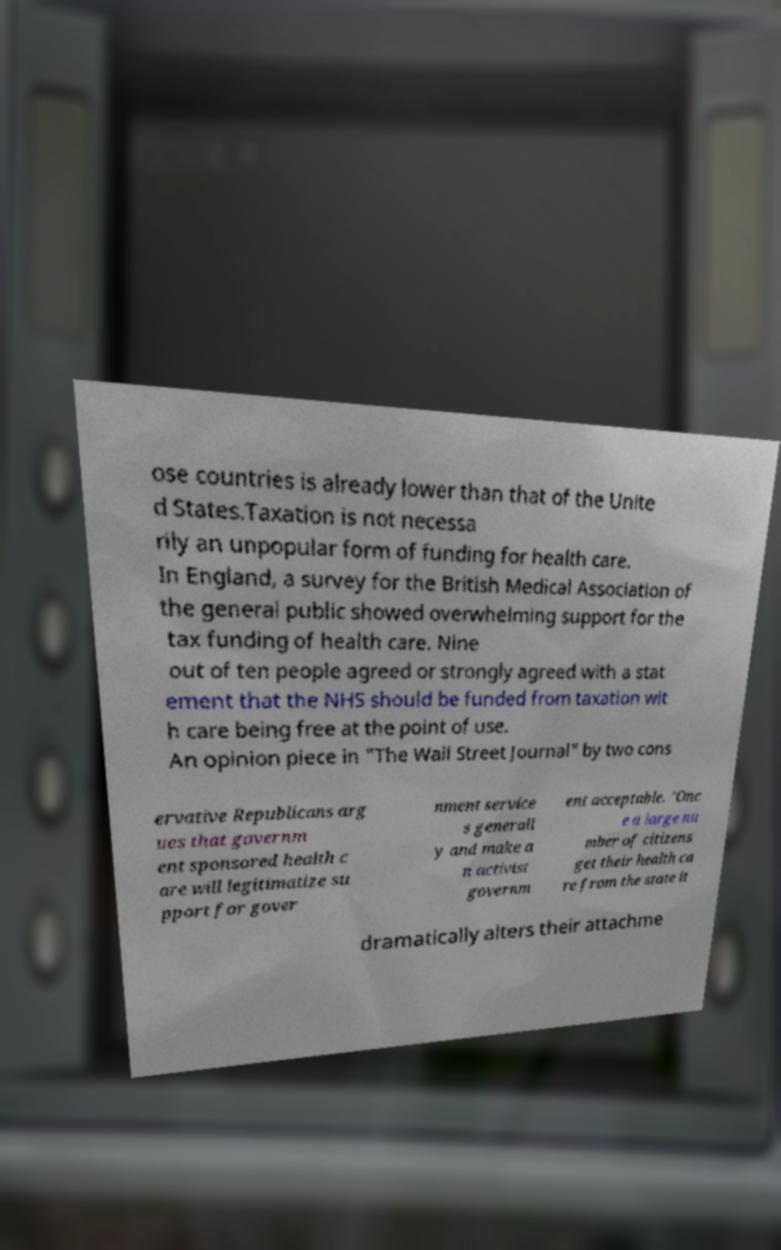There's text embedded in this image that I need extracted. Can you transcribe it verbatim? ose countries is already lower than that of the Unite d States.Taxation is not necessa rily an unpopular form of funding for health care. In England, a survey for the British Medical Association of the general public showed overwhelming support for the tax funding of health care. Nine out of ten people agreed or strongly agreed with a stat ement that the NHS should be funded from taxation wit h care being free at the point of use. An opinion piece in "The Wall Street Journal" by two cons ervative Republicans arg ues that governm ent sponsored health c are will legitimatize su pport for gover nment service s generall y and make a n activist governm ent acceptable. "Onc e a large nu mber of citizens get their health ca re from the state it dramatically alters their attachme 